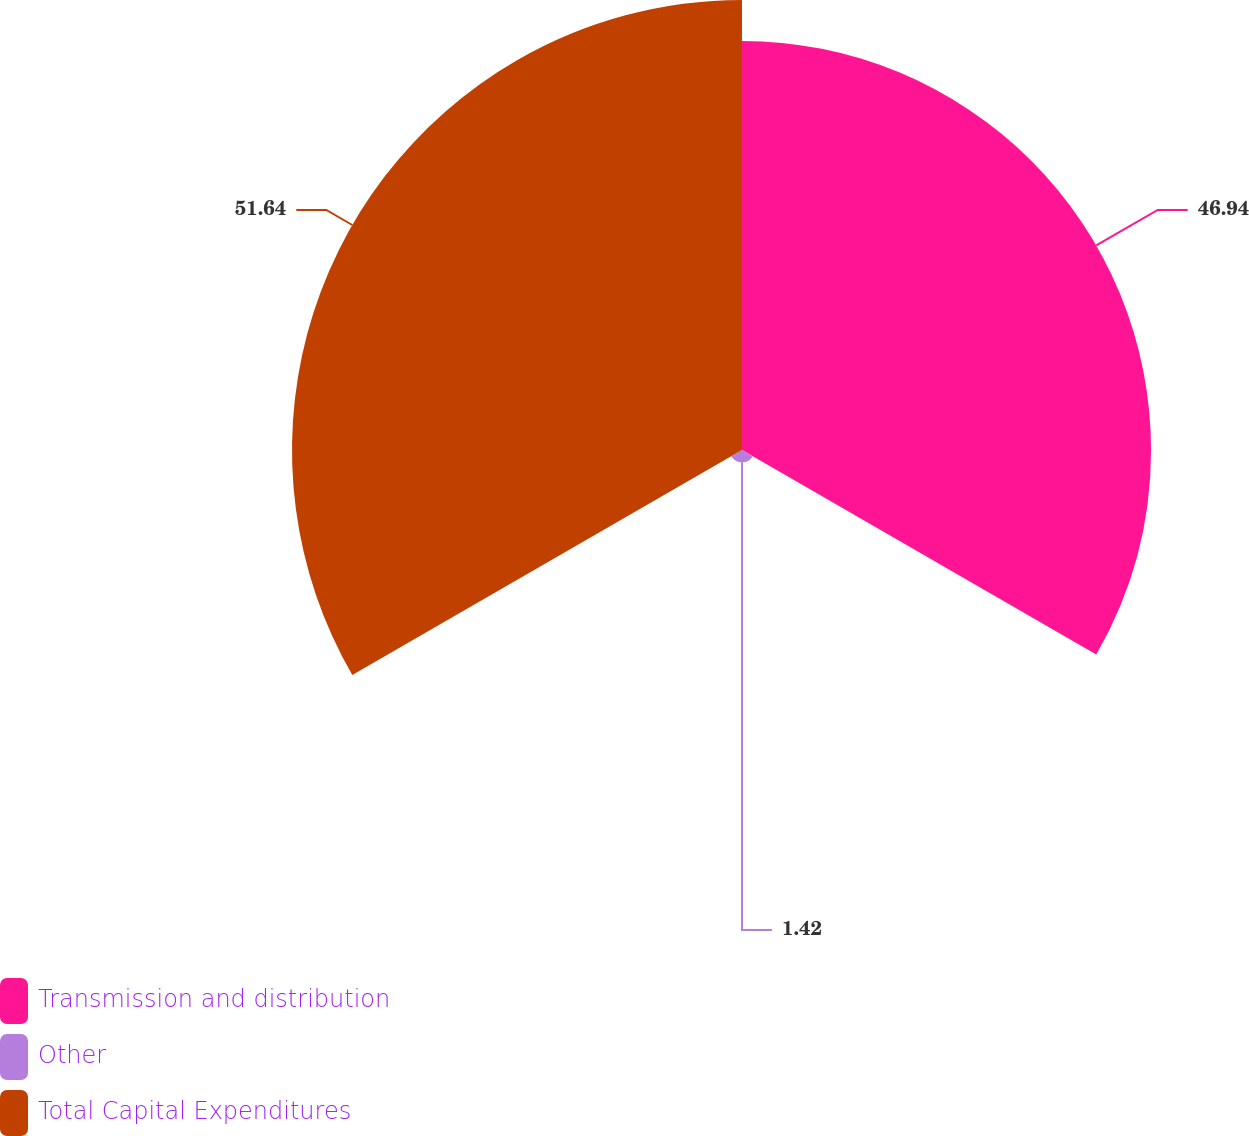<chart> <loc_0><loc_0><loc_500><loc_500><pie_chart><fcel>Transmission and distribution<fcel>Other<fcel>Total Capital Expenditures<nl><fcel>46.94%<fcel>1.42%<fcel>51.64%<nl></chart> 